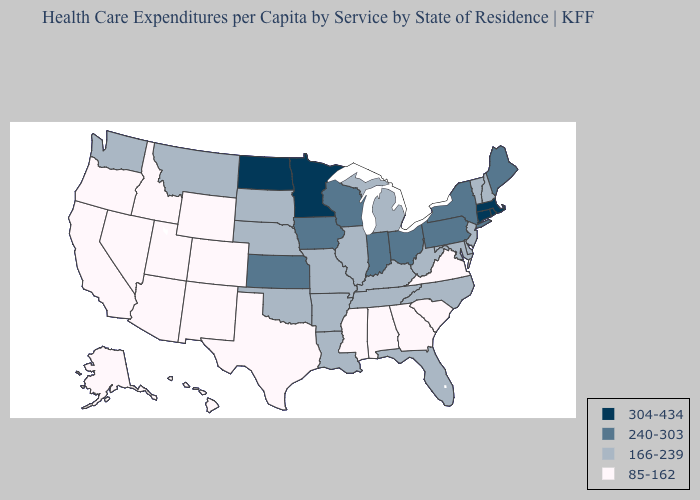Name the states that have a value in the range 240-303?
Answer briefly. Indiana, Iowa, Kansas, Maine, New York, Ohio, Pennsylvania, Wisconsin. Does Minnesota have the same value as Connecticut?
Answer briefly. Yes. What is the lowest value in states that border North Dakota?
Answer briefly. 166-239. What is the lowest value in the Northeast?
Write a very short answer. 166-239. Does the map have missing data?
Give a very brief answer. No. Among the states that border Delaware , does Pennsylvania have the highest value?
Answer briefly. Yes. What is the value of New Mexico?
Give a very brief answer. 85-162. What is the lowest value in the South?
Concise answer only. 85-162. Name the states that have a value in the range 304-434?
Concise answer only. Connecticut, Massachusetts, Minnesota, North Dakota, Rhode Island. What is the lowest value in states that border South Carolina?
Keep it brief. 85-162. Which states have the lowest value in the USA?
Give a very brief answer. Alabama, Alaska, Arizona, California, Colorado, Georgia, Hawaii, Idaho, Mississippi, Nevada, New Mexico, Oregon, South Carolina, Texas, Utah, Virginia, Wyoming. Does Maine have a higher value than Ohio?
Concise answer only. No. Name the states that have a value in the range 304-434?
Concise answer only. Connecticut, Massachusetts, Minnesota, North Dakota, Rhode Island. Name the states that have a value in the range 166-239?
Write a very short answer. Arkansas, Delaware, Florida, Illinois, Kentucky, Louisiana, Maryland, Michigan, Missouri, Montana, Nebraska, New Hampshire, New Jersey, North Carolina, Oklahoma, South Dakota, Tennessee, Vermont, Washington, West Virginia. Name the states that have a value in the range 304-434?
Short answer required. Connecticut, Massachusetts, Minnesota, North Dakota, Rhode Island. 